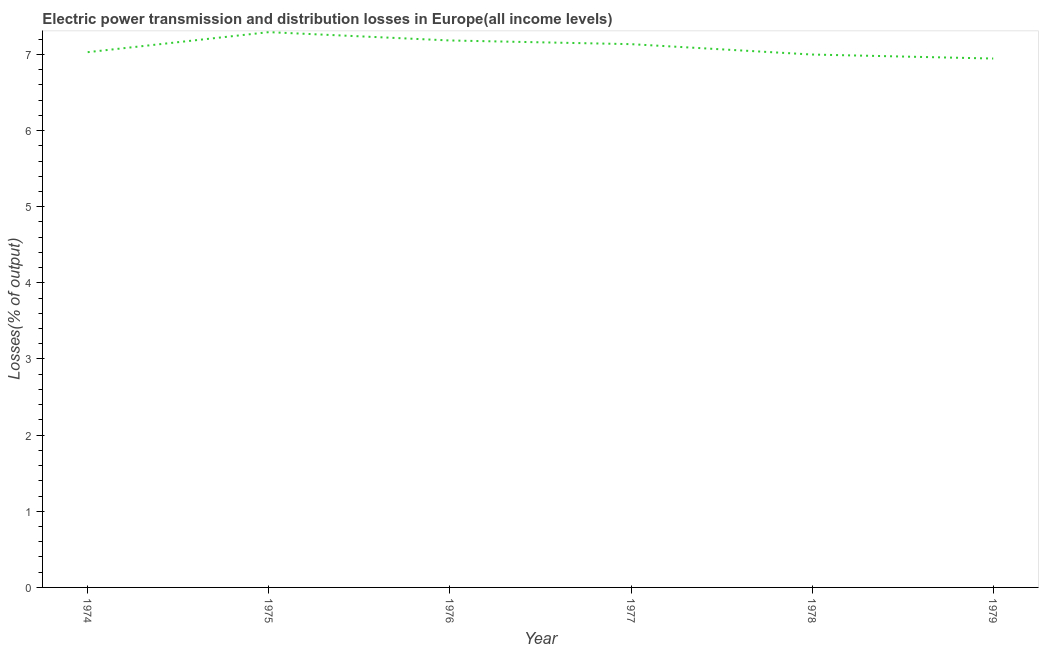What is the electric power transmission and distribution losses in 1979?
Make the answer very short. 6.95. Across all years, what is the maximum electric power transmission and distribution losses?
Your answer should be very brief. 7.29. Across all years, what is the minimum electric power transmission and distribution losses?
Ensure brevity in your answer.  6.95. In which year was the electric power transmission and distribution losses maximum?
Offer a terse response. 1975. In which year was the electric power transmission and distribution losses minimum?
Make the answer very short. 1979. What is the sum of the electric power transmission and distribution losses?
Offer a terse response. 42.58. What is the difference between the electric power transmission and distribution losses in 1975 and 1976?
Your answer should be compact. 0.11. What is the average electric power transmission and distribution losses per year?
Offer a very short reply. 7.1. What is the median electric power transmission and distribution losses?
Your response must be concise. 7.08. Do a majority of the years between 1975 and 1974 (inclusive) have electric power transmission and distribution losses greater than 6.8 %?
Ensure brevity in your answer.  No. What is the ratio of the electric power transmission and distribution losses in 1974 to that in 1975?
Make the answer very short. 0.96. What is the difference between the highest and the second highest electric power transmission and distribution losses?
Make the answer very short. 0.11. What is the difference between the highest and the lowest electric power transmission and distribution losses?
Offer a very short reply. 0.35. How many lines are there?
Make the answer very short. 1. What is the difference between two consecutive major ticks on the Y-axis?
Ensure brevity in your answer.  1. Are the values on the major ticks of Y-axis written in scientific E-notation?
Make the answer very short. No. Does the graph contain grids?
Provide a short and direct response. No. What is the title of the graph?
Make the answer very short. Electric power transmission and distribution losses in Europe(all income levels). What is the label or title of the Y-axis?
Provide a succinct answer. Losses(% of output). What is the Losses(% of output) of 1974?
Your answer should be very brief. 7.03. What is the Losses(% of output) of 1975?
Provide a short and direct response. 7.29. What is the Losses(% of output) of 1976?
Provide a short and direct response. 7.18. What is the Losses(% of output) in 1977?
Offer a very short reply. 7.13. What is the Losses(% of output) of 1978?
Offer a terse response. 7. What is the Losses(% of output) of 1979?
Keep it short and to the point. 6.95. What is the difference between the Losses(% of output) in 1974 and 1975?
Keep it short and to the point. -0.26. What is the difference between the Losses(% of output) in 1974 and 1976?
Give a very brief answer. -0.15. What is the difference between the Losses(% of output) in 1974 and 1977?
Give a very brief answer. -0.11. What is the difference between the Losses(% of output) in 1974 and 1978?
Your answer should be very brief. 0.03. What is the difference between the Losses(% of output) in 1974 and 1979?
Your answer should be very brief. 0.08. What is the difference between the Losses(% of output) in 1975 and 1976?
Ensure brevity in your answer.  0.11. What is the difference between the Losses(% of output) in 1975 and 1977?
Keep it short and to the point. 0.16. What is the difference between the Losses(% of output) in 1975 and 1978?
Give a very brief answer. 0.29. What is the difference between the Losses(% of output) in 1975 and 1979?
Keep it short and to the point. 0.35. What is the difference between the Losses(% of output) in 1976 and 1977?
Make the answer very short. 0.05. What is the difference between the Losses(% of output) in 1976 and 1978?
Your answer should be very brief. 0.18. What is the difference between the Losses(% of output) in 1976 and 1979?
Make the answer very short. 0.24. What is the difference between the Losses(% of output) in 1977 and 1978?
Your answer should be compact. 0.14. What is the difference between the Losses(% of output) in 1977 and 1979?
Offer a very short reply. 0.19. What is the difference between the Losses(% of output) in 1978 and 1979?
Give a very brief answer. 0.05. What is the ratio of the Losses(% of output) in 1974 to that in 1976?
Your response must be concise. 0.98. What is the ratio of the Losses(% of output) in 1974 to that in 1978?
Ensure brevity in your answer.  1. What is the ratio of the Losses(% of output) in 1975 to that in 1977?
Offer a very short reply. 1.02. What is the ratio of the Losses(% of output) in 1975 to that in 1978?
Ensure brevity in your answer.  1.04. What is the ratio of the Losses(% of output) in 1975 to that in 1979?
Provide a succinct answer. 1.05. What is the ratio of the Losses(% of output) in 1976 to that in 1977?
Provide a succinct answer. 1.01. What is the ratio of the Losses(% of output) in 1976 to that in 1978?
Make the answer very short. 1.03. What is the ratio of the Losses(% of output) in 1976 to that in 1979?
Keep it short and to the point. 1.03. What is the ratio of the Losses(% of output) in 1977 to that in 1978?
Ensure brevity in your answer.  1.02. What is the ratio of the Losses(% of output) in 1977 to that in 1979?
Give a very brief answer. 1.03. 